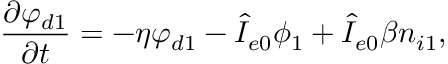Convert formula to latex. <formula><loc_0><loc_0><loc_500><loc_500>\frac { \partial \varphi _ { d 1 } } { \partial t } = - \eta \varphi _ { d 1 } - \hat { I } _ { e 0 } \phi _ { 1 } + \hat { I } _ { e 0 } \beta n _ { i 1 } ,</formula> 